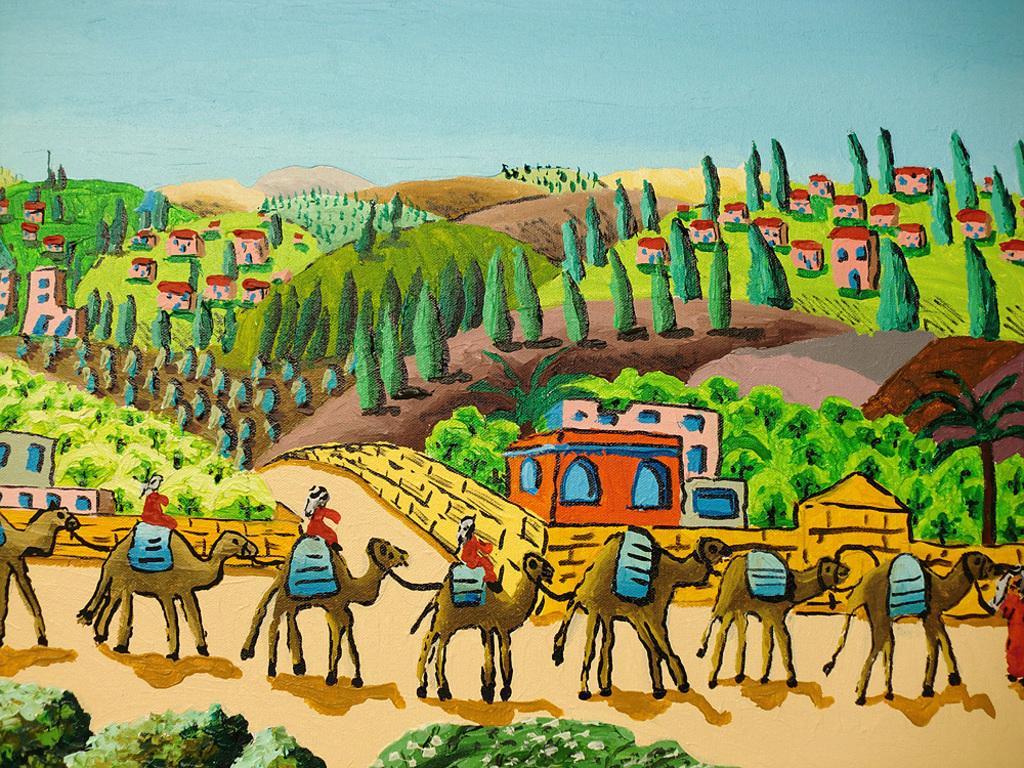Can you describe this image briefly? It is a painting,there are images of camels,houses,roads,trees and greenery and mountains. 